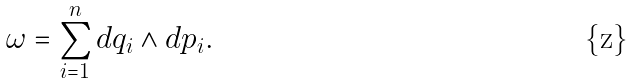Convert formula to latex. <formula><loc_0><loc_0><loc_500><loc_500>\omega = \sum _ { i = 1 } ^ { n } d q _ { i } \wedge d p _ { i } .</formula> 